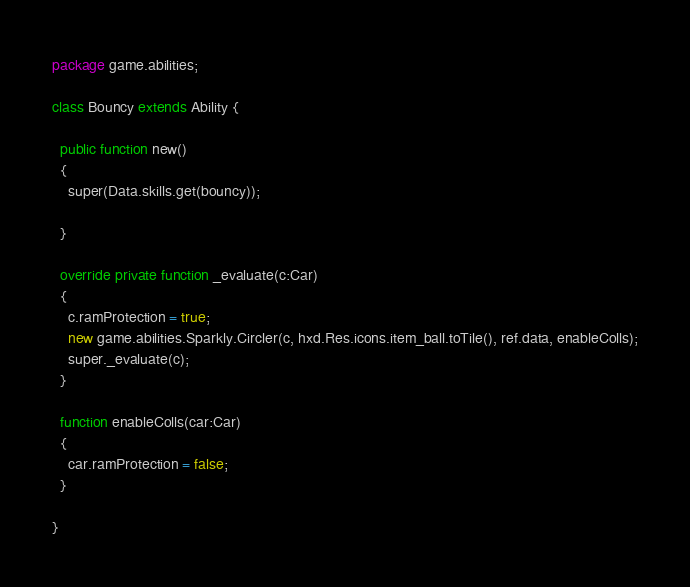<code> <loc_0><loc_0><loc_500><loc_500><_Haxe_>package game.abilities;

class Bouncy extends Ability {
  
  public function new()
  {
    super(Data.skills.get(bouncy));
    
  }
  
  override private function _evaluate(c:Car)
  {
    c.ramProtection = true;
    new game.abilities.Sparkly.Circler(c, hxd.Res.icons.item_ball.toTile(), ref.data, enableColls);
    super._evaluate(c);
  }
  
  function enableColls(car:Car)
  {
    car.ramProtection = false;
  }
  
}</code> 